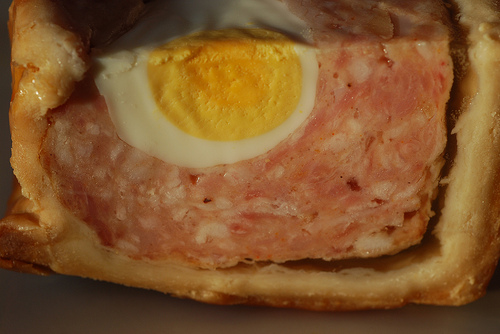<image>
Can you confirm if the egg is in front of the meat? No. The egg is not in front of the meat. The spatial positioning shows a different relationship between these objects. 